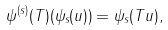<formula> <loc_0><loc_0><loc_500><loc_500>\psi ^ { ( s ) } ( T ) ( \psi _ { s } ( u ) ) = \psi _ { s } ( T u ) ,</formula> 